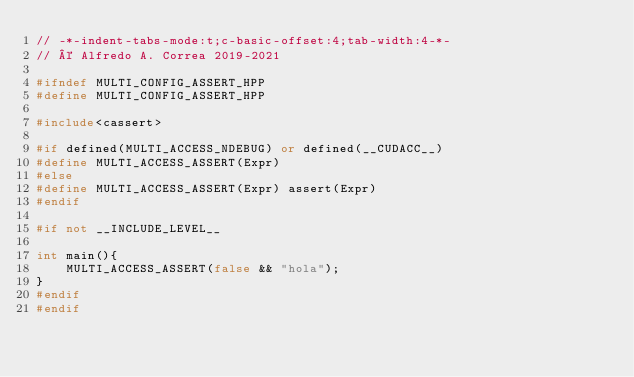<code> <loc_0><loc_0><loc_500><loc_500><_C++_>// -*-indent-tabs-mode:t;c-basic-offset:4;tab-width:4-*-
// © Alfredo A. Correa 2019-2021

#ifndef MULTI_CONFIG_ASSERT_HPP
#define MULTI_CONFIG_ASSERT_HPP

#include<cassert>

#if defined(MULTI_ACCESS_NDEBUG) or defined(__CUDACC__)
#define MULTI_ACCESS_ASSERT(Expr)
#else
#define MULTI_ACCESS_ASSERT(Expr) assert(Expr)
#endif

#if not __INCLUDE_LEVEL__

int main(){
	MULTI_ACCESS_ASSERT(false && "hola");
}
#endif
#endif

</code> 